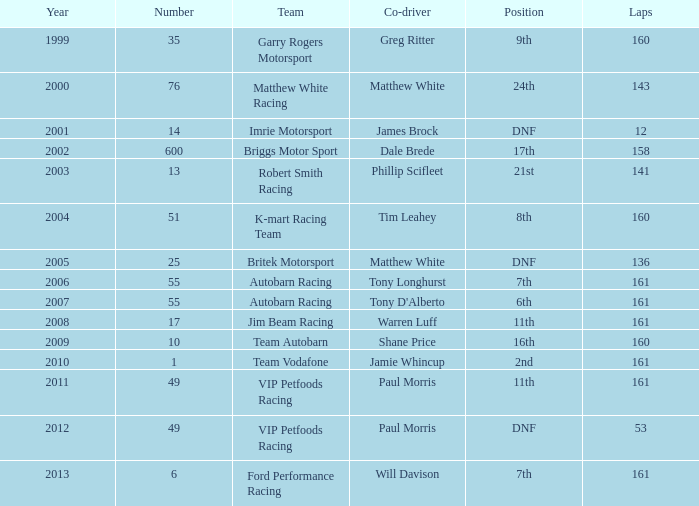Prior to 2001, what was the lowest lap count for a team that had a dnf standing and a number under 25? None. 